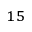Convert formula to latex. <formula><loc_0><loc_0><loc_500><loc_500>^ { 1 5 }</formula> 